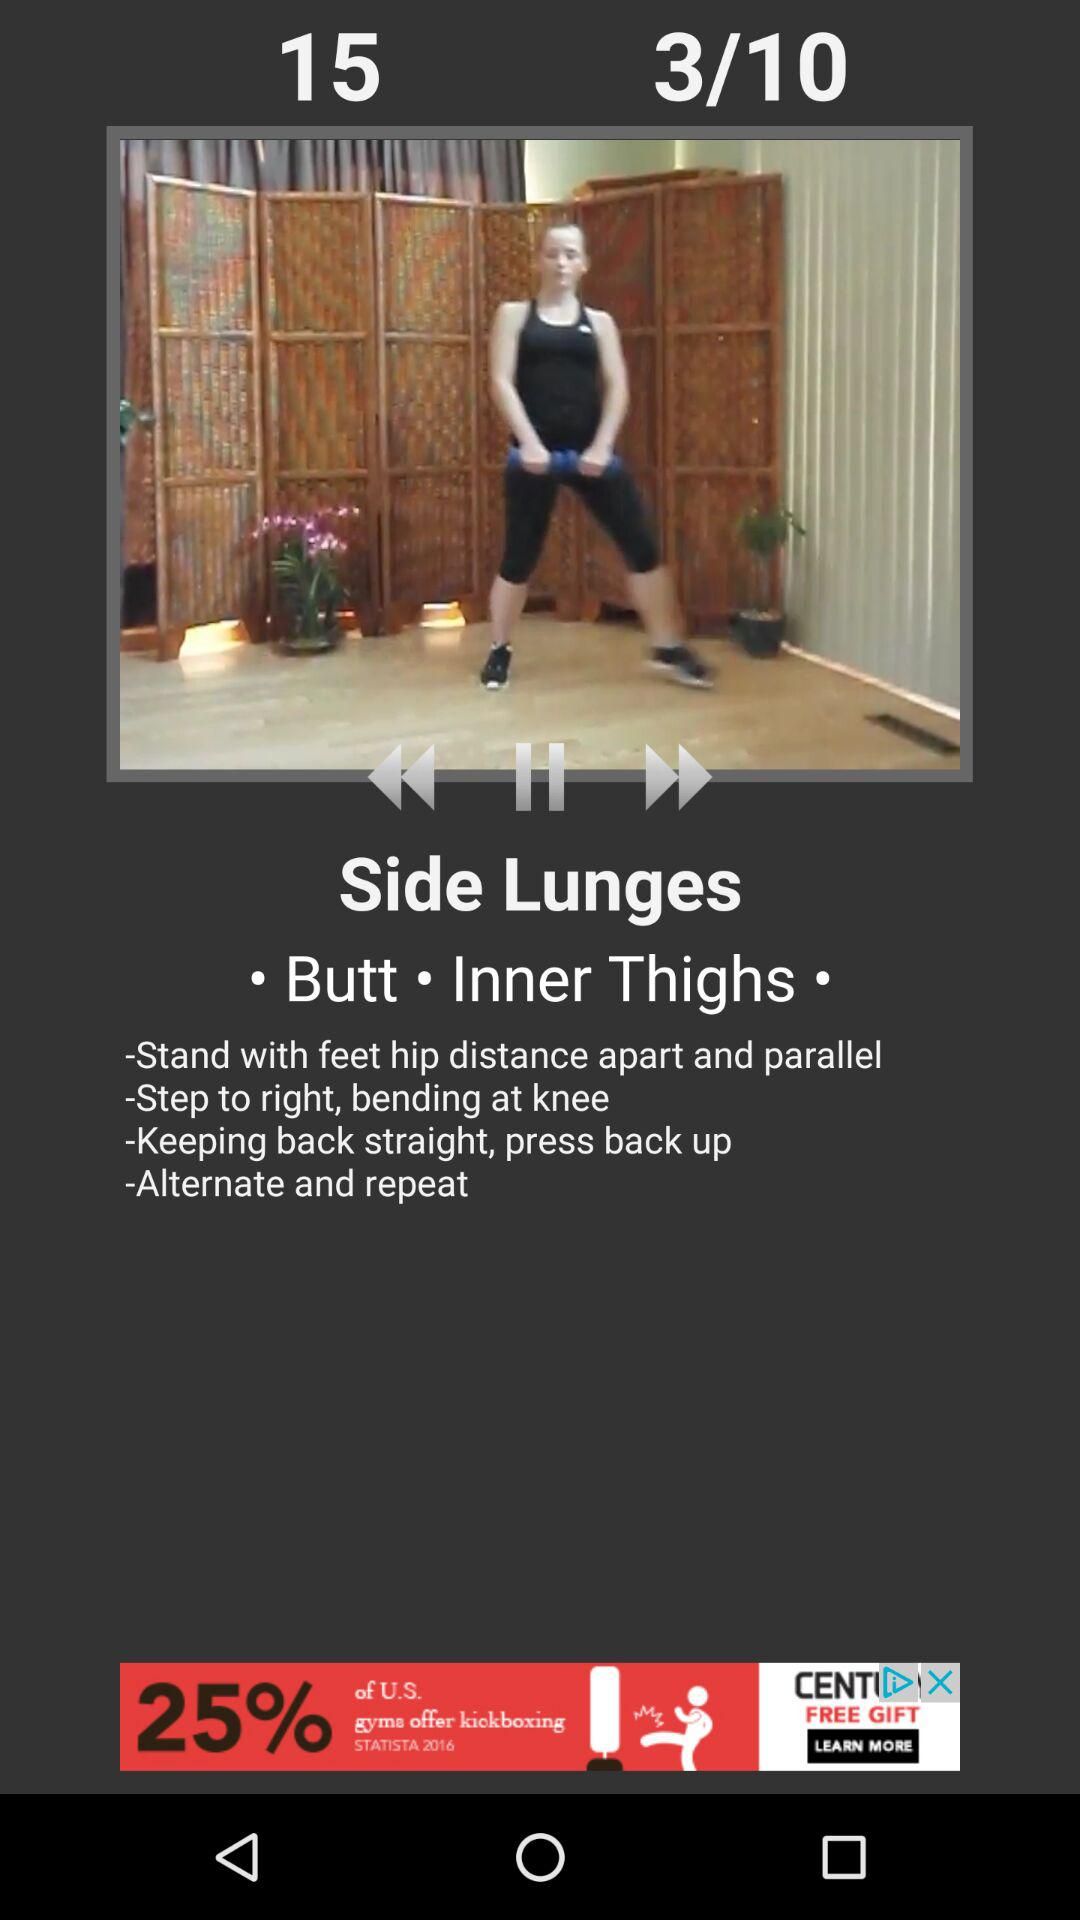How many muscle groups are targeted in the exercise?
Answer the question using a single word or phrase. 2 